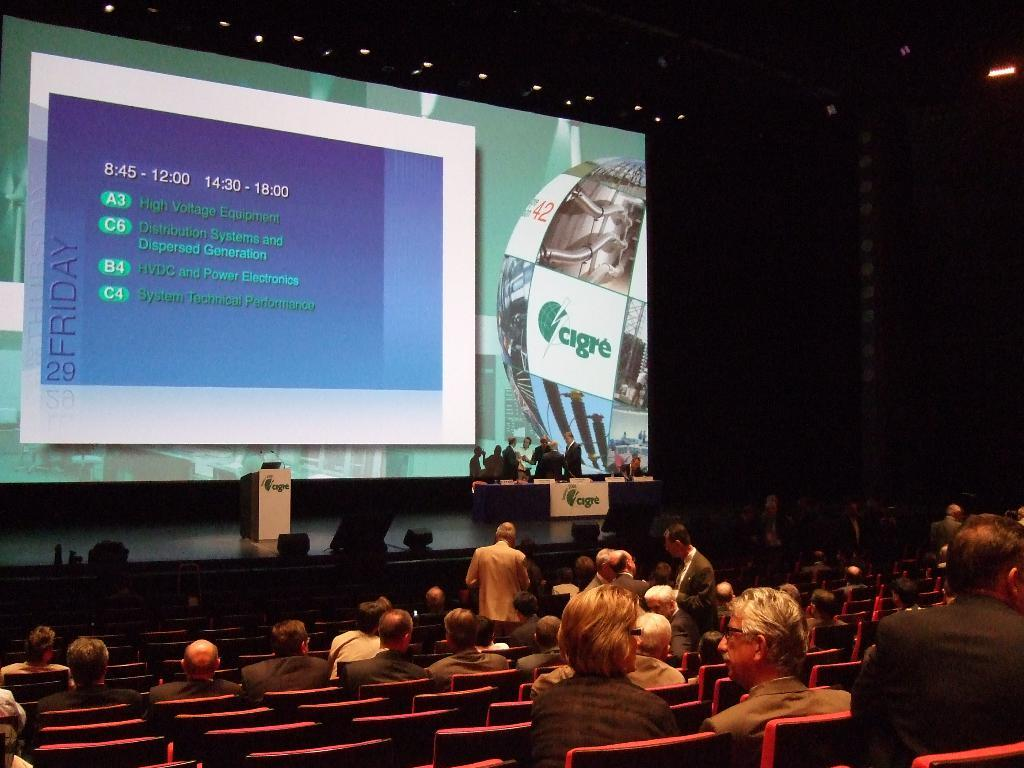<image>
Describe the image concisely. Cigre convention being held in a theater on Friday the 29th. 